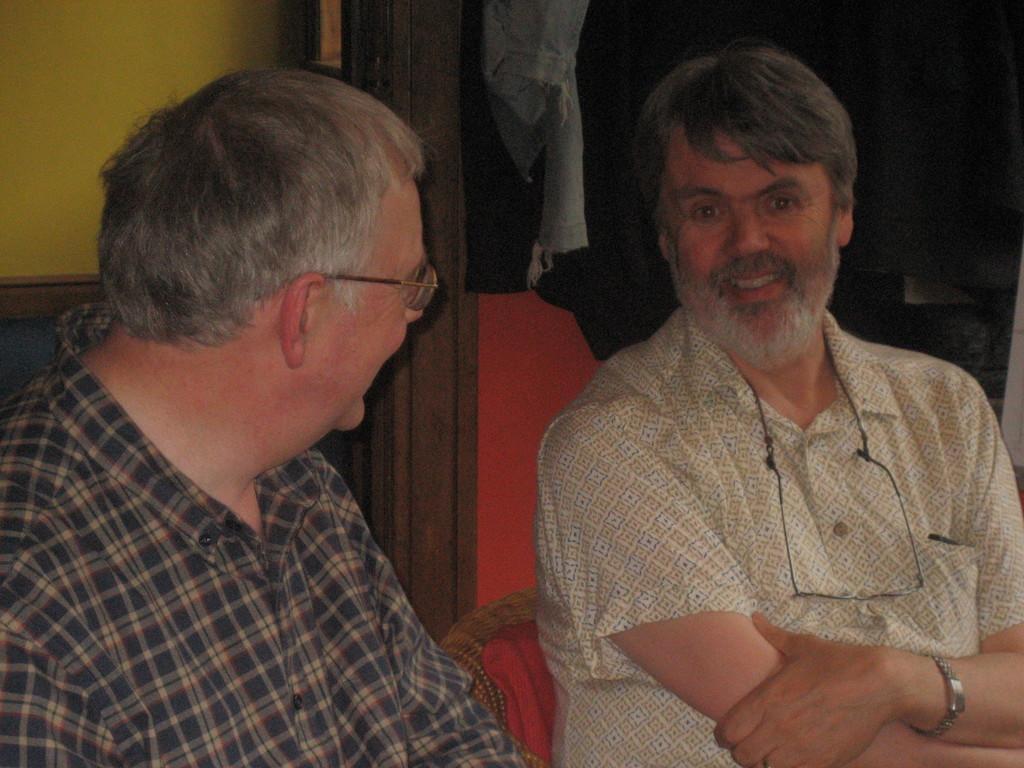In one or two sentences, can you explain what this image depicts? In this image we can see two persons are sitting, and smiling, he is wearing the glasses, at back here is the wall. 